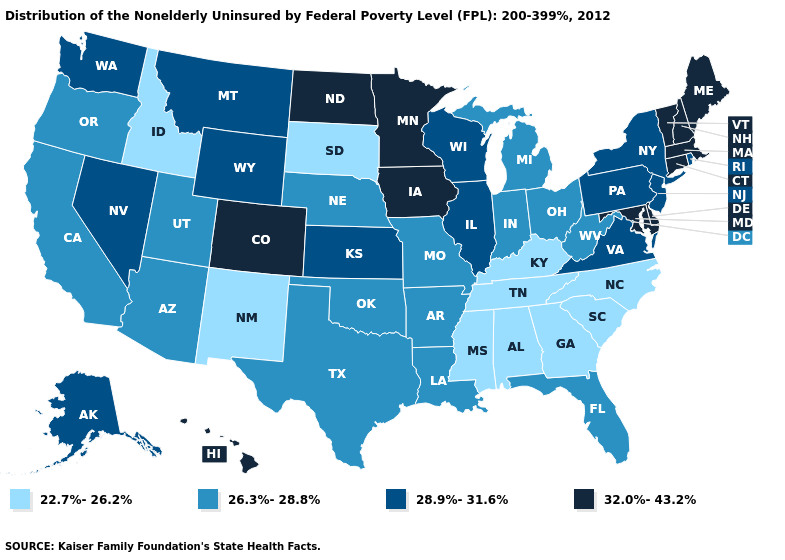What is the highest value in the USA?
Write a very short answer. 32.0%-43.2%. Name the states that have a value in the range 32.0%-43.2%?
Concise answer only. Colorado, Connecticut, Delaware, Hawaii, Iowa, Maine, Maryland, Massachusetts, Minnesota, New Hampshire, North Dakota, Vermont. What is the value of Arkansas?
Concise answer only. 26.3%-28.8%. Does Idaho have the lowest value in the USA?
Quick response, please. Yes. Name the states that have a value in the range 32.0%-43.2%?
Quick response, please. Colorado, Connecticut, Delaware, Hawaii, Iowa, Maine, Maryland, Massachusetts, Minnesota, New Hampshire, North Dakota, Vermont. What is the highest value in the West ?
Concise answer only. 32.0%-43.2%. Name the states that have a value in the range 28.9%-31.6%?
Be succinct. Alaska, Illinois, Kansas, Montana, Nevada, New Jersey, New York, Pennsylvania, Rhode Island, Virginia, Washington, Wisconsin, Wyoming. What is the value of New Hampshire?
Answer briefly. 32.0%-43.2%. Is the legend a continuous bar?
Short answer required. No. Name the states that have a value in the range 32.0%-43.2%?
Keep it brief. Colorado, Connecticut, Delaware, Hawaii, Iowa, Maine, Maryland, Massachusetts, Minnesota, New Hampshire, North Dakota, Vermont. Does the first symbol in the legend represent the smallest category?
Write a very short answer. Yes. Which states hav the highest value in the South?
Give a very brief answer. Delaware, Maryland. Name the states that have a value in the range 22.7%-26.2%?
Quick response, please. Alabama, Georgia, Idaho, Kentucky, Mississippi, New Mexico, North Carolina, South Carolina, South Dakota, Tennessee. What is the value of Montana?
Short answer required. 28.9%-31.6%. Name the states that have a value in the range 22.7%-26.2%?
Write a very short answer. Alabama, Georgia, Idaho, Kentucky, Mississippi, New Mexico, North Carolina, South Carolina, South Dakota, Tennessee. 